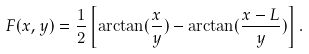<formula> <loc_0><loc_0><loc_500><loc_500>F ( x , y ) = \frac { 1 } { 2 } \left [ \arctan ( \frac { x } { y } ) - \arctan ( \frac { x - L } { y } ) \right ] .</formula> 